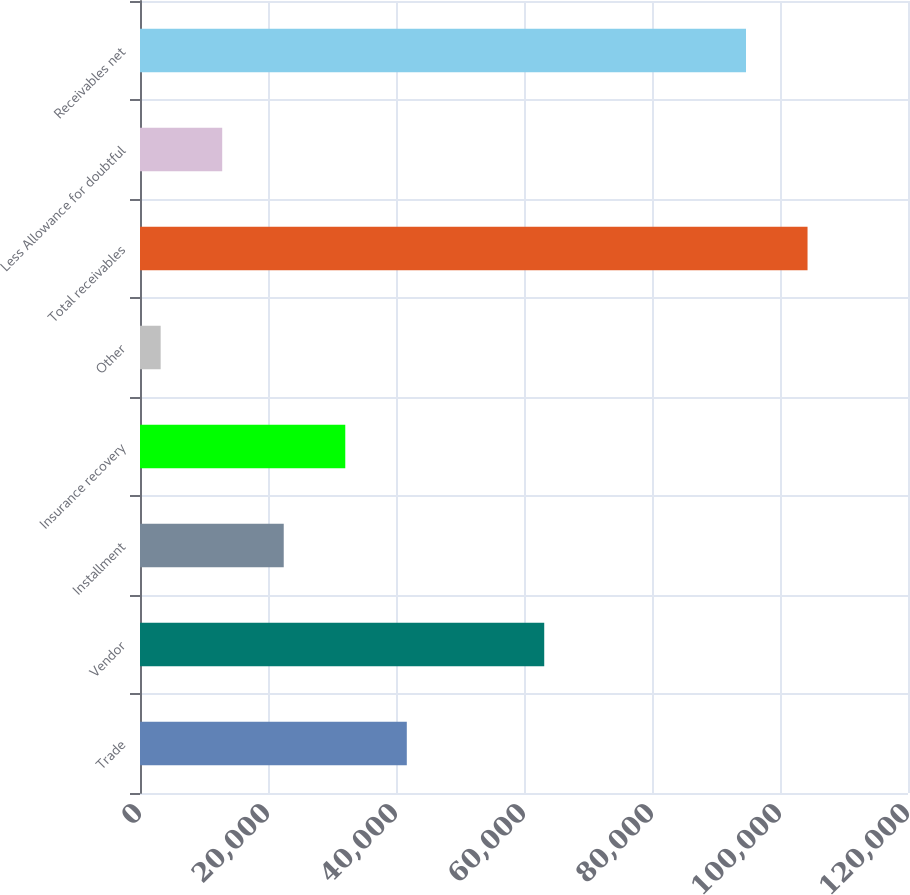Convert chart to OTSL. <chart><loc_0><loc_0><loc_500><loc_500><bar_chart><fcel>Trade<fcel>Vendor<fcel>Installment<fcel>Insurance recovery<fcel>Other<fcel>Total receivables<fcel>Less Allowance for doubtful<fcel>Receivables net<nl><fcel>41688<fcel>63161<fcel>22459<fcel>32073.5<fcel>3230<fcel>104304<fcel>12844.5<fcel>94689<nl></chart> 